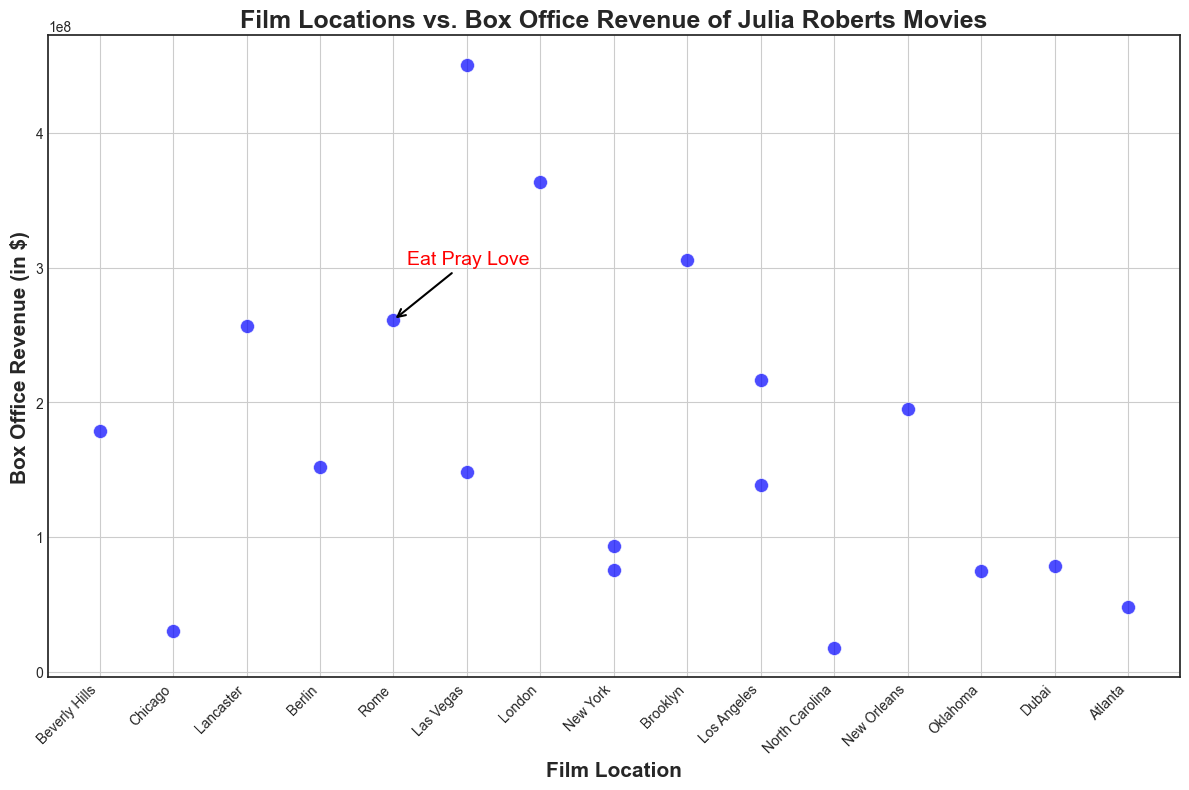What's the box office revenue of "Eat Pray Love"? Look at the annotation on the scatter plot which marks the box office revenue for "Eat Pray Love".
Answer: $260,963,487 Which movie has the highest box office revenue, and what is that revenue? Identify the point with the maximum height on the y-axis (box office revenue), and check the corresponding movie and revenue.
Answer: Ocean's Eleven, $450,717,150 Compare the box office revenues of movies filmed in Las Vegas. Which movie made more? Find the two Las Vegas points on the scatter plot. Compare their heights (box office revenues).
Answer: Ocean's Eleven made more than The Mexican Which film location has the lowest box office revenue and what is the revenue? Identify the point with the minimum height on the y-axis. Look at the x-axis value (location) and corresponding revenue.
Answer: North Carolina, $17,545,602 What is the average box office revenue of movies filmed in Los Angeles? Find the points corresponding to Los Angeles. Sum their box office revenues and divide by the number of these movies.
Answer: $177,371,778 How many movies have a box office revenue above $300 million? Count the number of points above the $300 million mark on the y-axis.
Answer: 3 Which location has the most movies, and what are their corresponding box office revenues? Count the number of points for each location on the x-axis and identify the maximum. List the revenues of the movies from that location.
Answer: Los Angeles, $138,257,901 and $216,485,654 What is the difference in box office revenue between "Erin Brockovich" and "Runaway Bride"? Find the points for "Erin Brockovich" and "Runaway Bride". Subtract the lower revenue from the higher revenue.
Answer: $104,013,777 Compare the movies filmed in New York. Which one has the higher box office revenue, and by how much? Find the points for movies filmed in New York. Compare their heights and subtract the lower revenue from the higher revenue.
Answer: Conspiracy Theory and Money Monster, $18,268,234 What is the total box office revenue for movies filmed in locations starting with the letter 'L'? Identify the points for locations starting with 'L' (Lancaster, Berlin, London, Los Angeles). Sum their corresponding revenues.
Answer: $1,360,992,856 